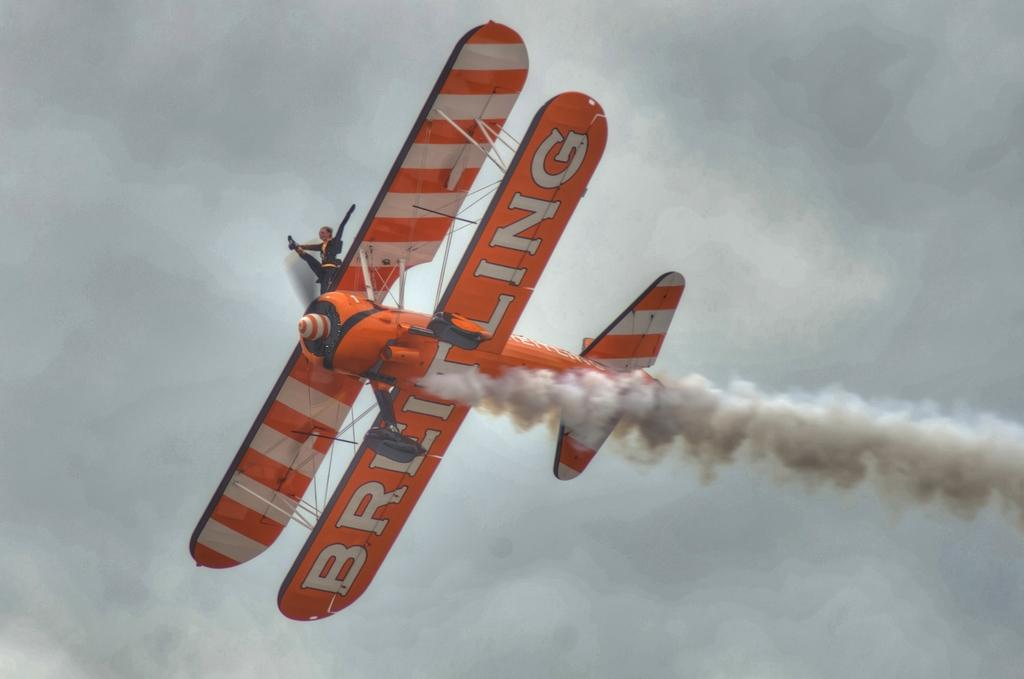<image>
Summarize the visual content of the image. A picture of an airplane with BREITLING written on it. 